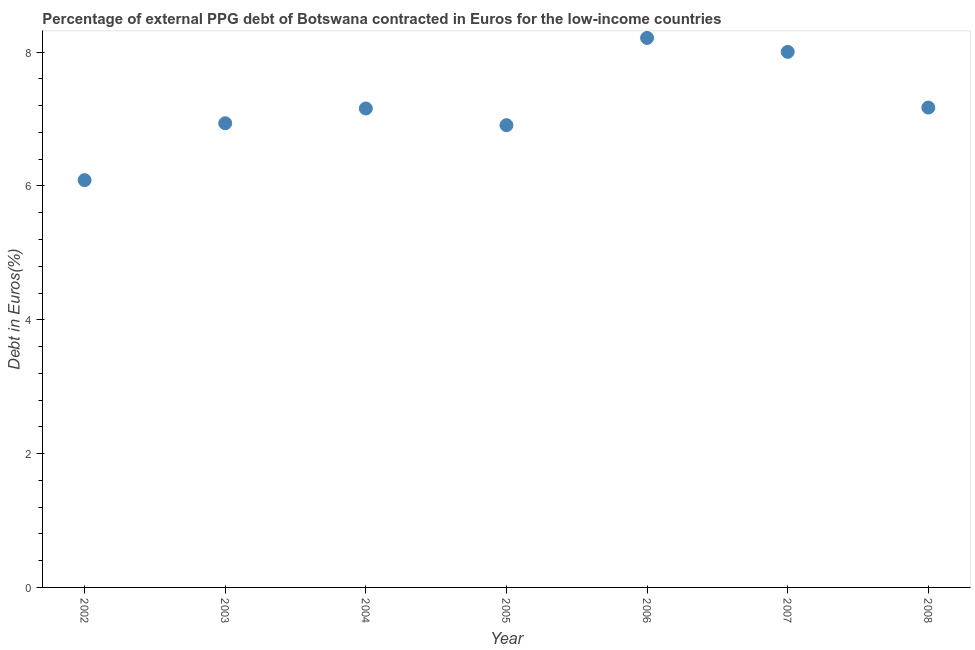What is the currency composition of ppg debt in 2002?
Your response must be concise. 6.09. Across all years, what is the maximum currency composition of ppg debt?
Give a very brief answer. 8.21. Across all years, what is the minimum currency composition of ppg debt?
Provide a succinct answer. 6.09. What is the sum of the currency composition of ppg debt?
Ensure brevity in your answer.  50.48. What is the difference between the currency composition of ppg debt in 2002 and 2004?
Provide a short and direct response. -1.07. What is the average currency composition of ppg debt per year?
Your answer should be very brief. 7.21. What is the median currency composition of ppg debt?
Give a very brief answer. 7.16. In how many years, is the currency composition of ppg debt greater than 6 %?
Your answer should be compact. 7. Do a majority of the years between 2003 and 2006 (inclusive) have currency composition of ppg debt greater than 2 %?
Provide a short and direct response. Yes. What is the ratio of the currency composition of ppg debt in 2002 to that in 2007?
Your response must be concise. 0.76. Is the difference between the currency composition of ppg debt in 2004 and 2008 greater than the difference between any two years?
Provide a succinct answer. No. What is the difference between the highest and the second highest currency composition of ppg debt?
Keep it short and to the point. 0.21. What is the difference between the highest and the lowest currency composition of ppg debt?
Your answer should be compact. 2.13. How many years are there in the graph?
Your response must be concise. 7. What is the difference between two consecutive major ticks on the Y-axis?
Give a very brief answer. 2. What is the title of the graph?
Keep it short and to the point. Percentage of external PPG debt of Botswana contracted in Euros for the low-income countries. What is the label or title of the X-axis?
Keep it short and to the point. Year. What is the label or title of the Y-axis?
Make the answer very short. Debt in Euros(%). What is the Debt in Euros(%) in 2002?
Offer a very short reply. 6.09. What is the Debt in Euros(%) in 2003?
Your response must be concise. 6.94. What is the Debt in Euros(%) in 2004?
Provide a succinct answer. 7.16. What is the Debt in Euros(%) in 2005?
Ensure brevity in your answer.  6.91. What is the Debt in Euros(%) in 2006?
Keep it short and to the point. 8.21. What is the Debt in Euros(%) in 2007?
Offer a very short reply. 8. What is the Debt in Euros(%) in 2008?
Your response must be concise. 7.17. What is the difference between the Debt in Euros(%) in 2002 and 2003?
Your response must be concise. -0.85. What is the difference between the Debt in Euros(%) in 2002 and 2004?
Provide a succinct answer. -1.07. What is the difference between the Debt in Euros(%) in 2002 and 2005?
Keep it short and to the point. -0.82. What is the difference between the Debt in Euros(%) in 2002 and 2006?
Make the answer very short. -2.13. What is the difference between the Debt in Euros(%) in 2002 and 2007?
Provide a short and direct response. -1.92. What is the difference between the Debt in Euros(%) in 2002 and 2008?
Keep it short and to the point. -1.08. What is the difference between the Debt in Euros(%) in 2003 and 2004?
Your answer should be very brief. -0.22. What is the difference between the Debt in Euros(%) in 2003 and 2005?
Ensure brevity in your answer.  0.03. What is the difference between the Debt in Euros(%) in 2003 and 2006?
Ensure brevity in your answer.  -1.28. What is the difference between the Debt in Euros(%) in 2003 and 2007?
Your answer should be compact. -1.07. What is the difference between the Debt in Euros(%) in 2003 and 2008?
Give a very brief answer. -0.23. What is the difference between the Debt in Euros(%) in 2004 and 2005?
Give a very brief answer. 0.25. What is the difference between the Debt in Euros(%) in 2004 and 2006?
Ensure brevity in your answer.  -1.05. What is the difference between the Debt in Euros(%) in 2004 and 2007?
Make the answer very short. -0.85. What is the difference between the Debt in Euros(%) in 2004 and 2008?
Your answer should be compact. -0.01. What is the difference between the Debt in Euros(%) in 2005 and 2006?
Provide a short and direct response. -1.3. What is the difference between the Debt in Euros(%) in 2005 and 2007?
Make the answer very short. -1.1. What is the difference between the Debt in Euros(%) in 2005 and 2008?
Your answer should be very brief. -0.26. What is the difference between the Debt in Euros(%) in 2006 and 2007?
Offer a very short reply. 0.21. What is the difference between the Debt in Euros(%) in 2006 and 2008?
Offer a very short reply. 1.04. What is the difference between the Debt in Euros(%) in 2007 and 2008?
Provide a succinct answer. 0.83. What is the ratio of the Debt in Euros(%) in 2002 to that in 2003?
Provide a succinct answer. 0.88. What is the ratio of the Debt in Euros(%) in 2002 to that in 2005?
Your response must be concise. 0.88. What is the ratio of the Debt in Euros(%) in 2002 to that in 2006?
Make the answer very short. 0.74. What is the ratio of the Debt in Euros(%) in 2002 to that in 2007?
Your answer should be compact. 0.76. What is the ratio of the Debt in Euros(%) in 2002 to that in 2008?
Ensure brevity in your answer.  0.85. What is the ratio of the Debt in Euros(%) in 2003 to that in 2004?
Your answer should be very brief. 0.97. What is the ratio of the Debt in Euros(%) in 2003 to that in 2006?
Provide a succinct answer. 0.84. What is the ratio of the Debt in Euros(%) in 2003 to that in 2007?
Give a very brief answer. 0.87. What is the ratio of the Debt in Euros(%) in 2003 to that in 2008?
Your response must be concise. 0.97. What is the ratio of the Debt in Euros(%) in 2004 to that in 2005?
Make the answer very short. 1.04. What is the ratio of the Debt in Euros(%) in 2004 to that in 2006?
Give a very brief answer. 0.87. What is the ratio of the Debt in Euros(%) in 2004 to that in 2007?
Your response must be concise. 0.89. What is the ratio of the Debt in Euros(%) in 2005 to that in 2006?
Offer a very short reply. 0.84. What is the ratio of the Debt in Euros(%) in 2005 to that in 2007?
Provide a succinct answer. 0.86. What is the ratio of the Debt in Euros(%) in 2005 to that in 2008?
Give a very brief answer. 0.96. What is the ratio of the Debt in Euros(%) in 2006 to that in 2007?
Give a very brief answer. 1.03. What is the ratio of the Debt in Euros(%) in 2006 to that in 2008?
Your answer should be compact. 1.15. What is the ratio of the Debt in Euros(%) in 2007 to that in 2008?
Give a very brief answer. 1.12. 